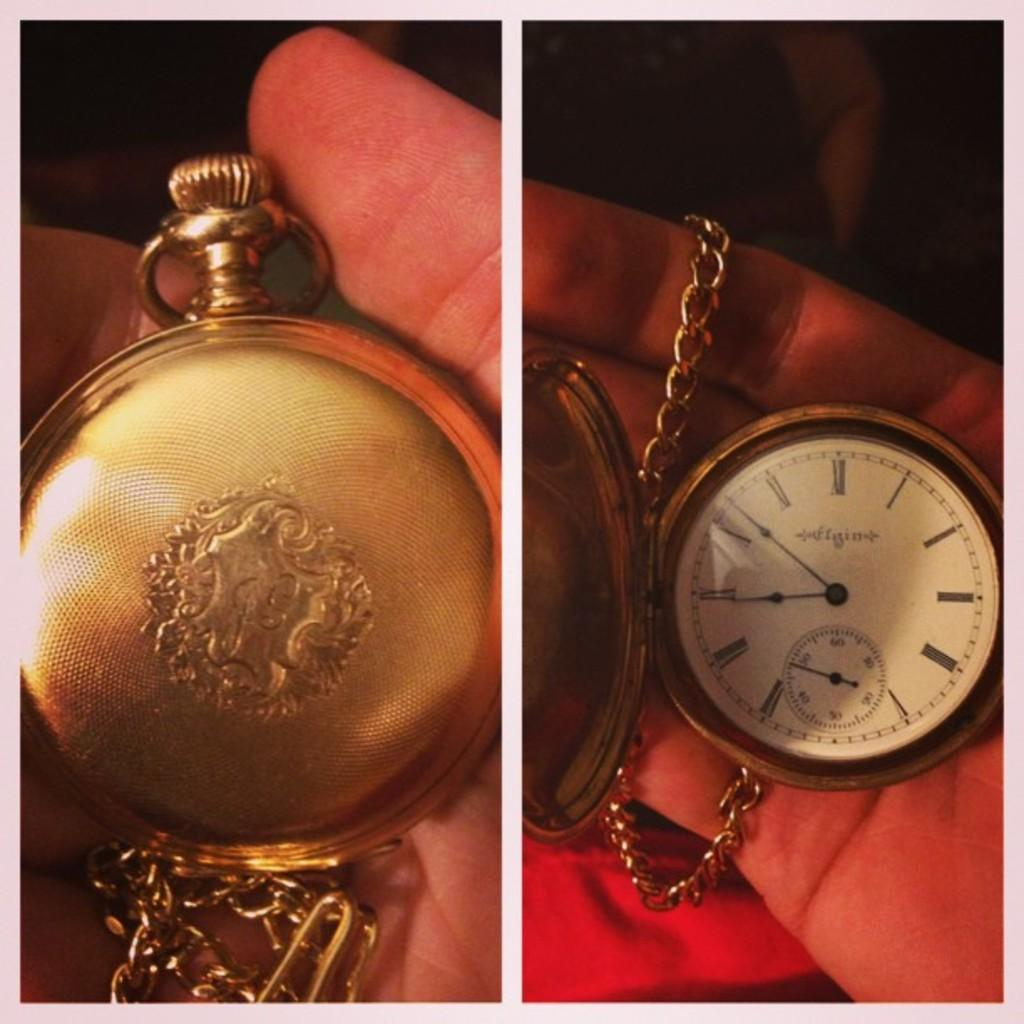<image>
Render a clear and concise summary of the photo. A person is holding a pocket watch that has the numeral III on the right side. 